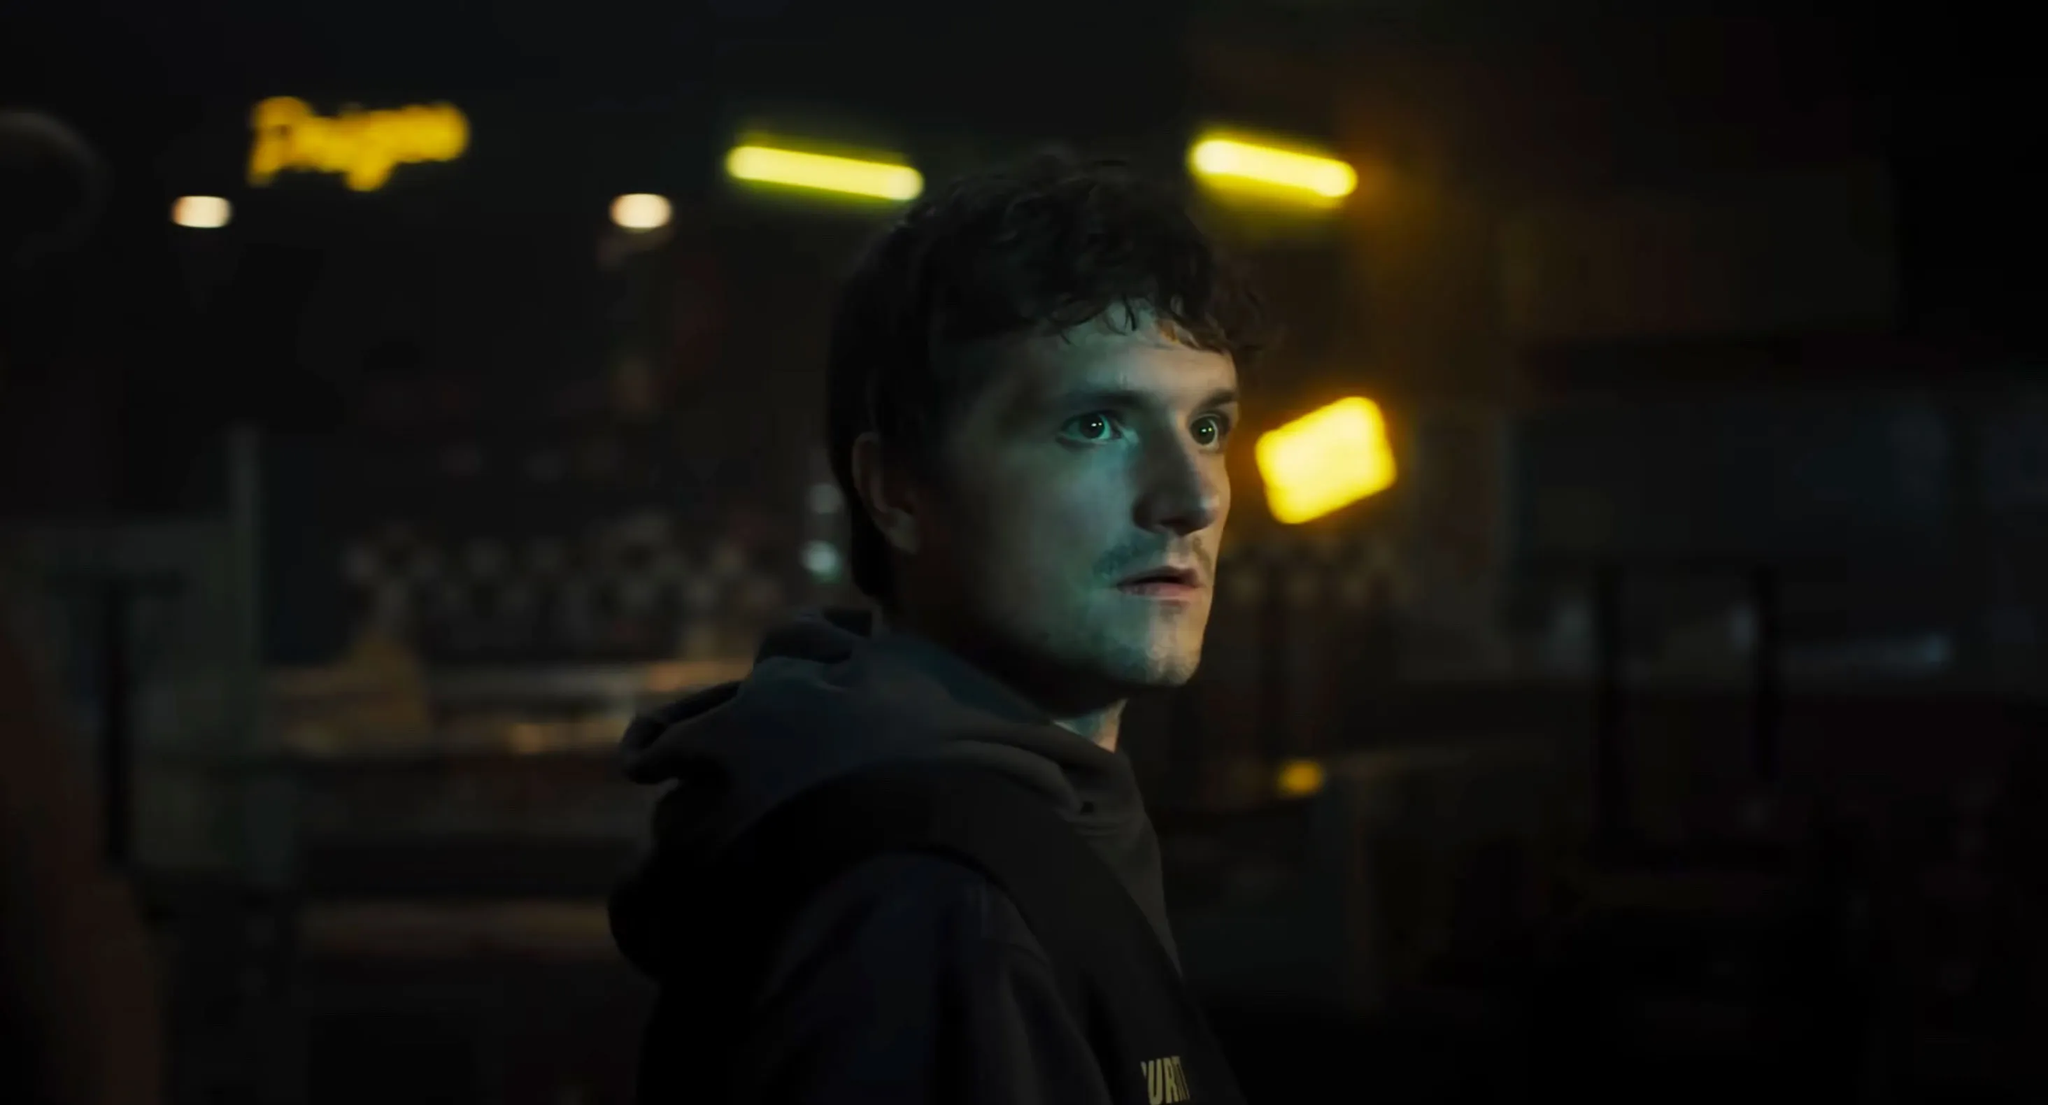How would you describe the atmosphere of the surroundings? The atmosphere of the surroundings is dark and tense. The dim lighting sets a somber tone, while the soft yellow lights add a touch of warmth amidst the gloom, creating a stark contrast. The blurred neon sign and checkerboard pattern on the wall introduce an element of urban decay and nostalgia. Overall, the setting feels like it’s part of a larger, hidden world; mysterious and filled with unspoken stories. Where in this world do you think this setting could exist? This setting could exist in an abandoned or rundown section of a once-thriving city. Perhaps it is in an old subway system repurposed as a refuge or secret base, far from the prying eyes of the authorities. The urban elements suggest it might be located in a place that was previously bustling with life but has since fallen into neglect, now serving as a hidden corner for those who operate on the edges of society. If this character were to narrate his own story, what might his thoughts be in this moment? "I never thought I would end up here, in the shadows of a forgotten city. Every corner whispers the past, but I can't afford to dwell on it. I have a mission, a purpose now. Every step I take in this darkness brings me closer to the light of hope. I must stay vigilant, for the sake of those who believe in me. This room, these lights, they're remnants of a world that's fighting to come back to life. And so am I... fighting for a future worth living." 